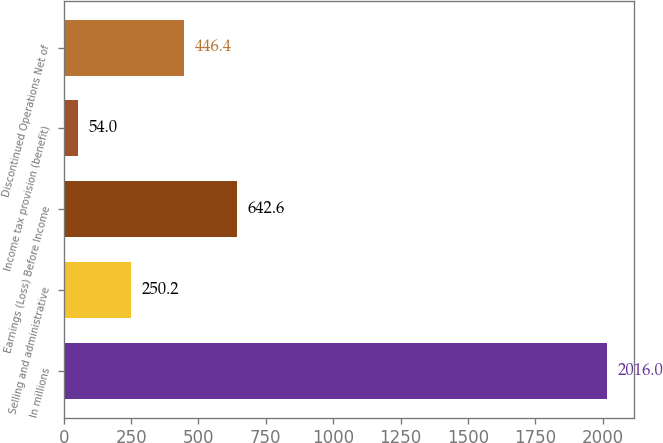Convert chart to OTSL. <chart><loc_0><loc_0><loc_500><loc_500><bar_chart><fcel>In millions<fcel>Selling and administrative<fcel>Earnings (Loss) Before Income<fcel>Income tax provision (benefit)<fcel>Discontinued Operations Net of<nl><fcel>2016<fcel>250.2<fcel>642.6<fcel>54<fcel>446.4<nl></chart> 